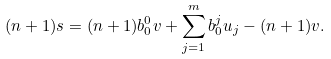Convert formula to latex. <formula><loc_0><loc_0><loc_500><loc_500>( n + 1 ) s = ( n + 1 ) b _ { 0 } ^ { 0 } v + \sum _ { j = 1 } ^ { m } b _ { 0 } ^ { j } u _ { j } - ( n + 1 ) v .</formula> 